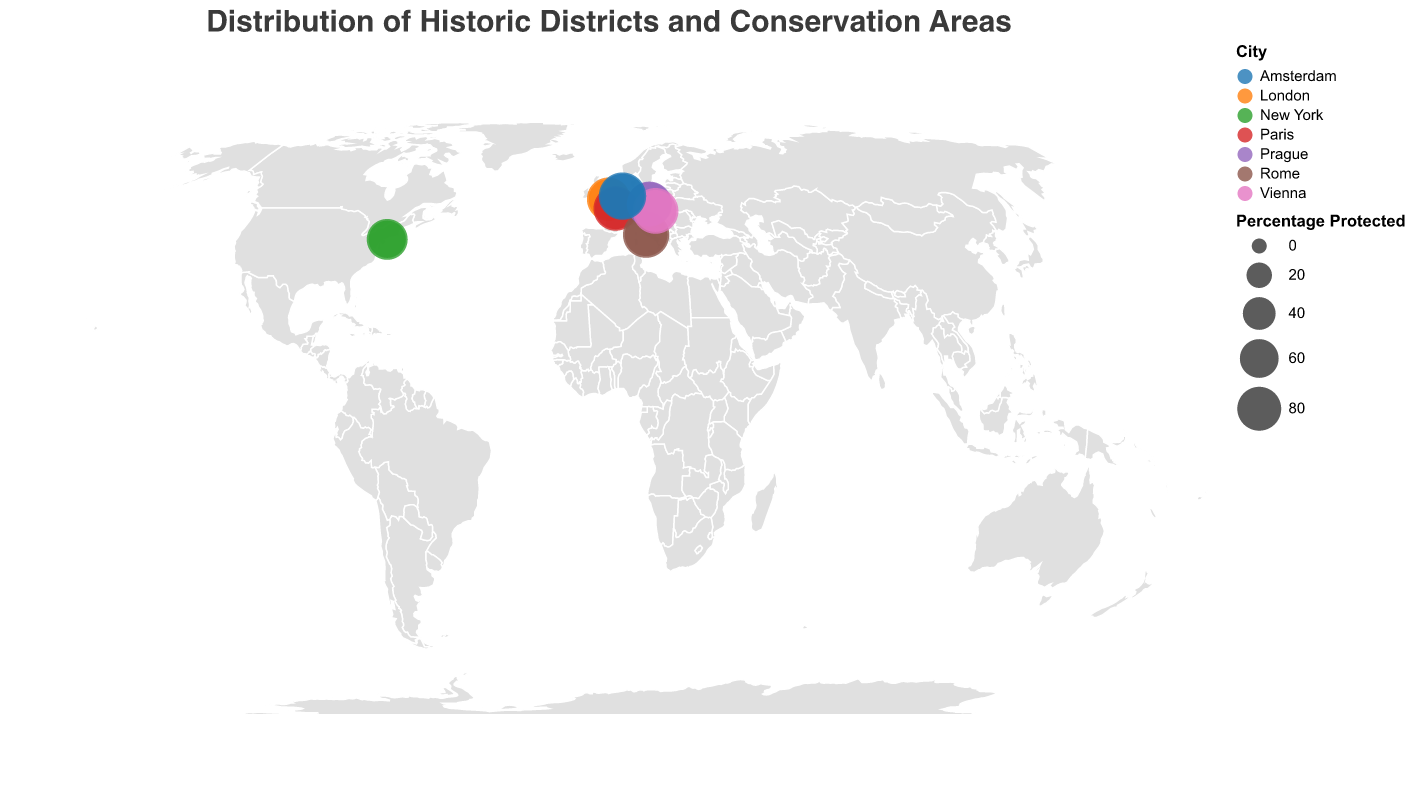What's the title of the figure? The title is prominently displayed at the top of the figure.
Answer: Distribution of Historic Districts and Conservation Areas Which city has the highest percentage of protected buildings in one of its districts? By looking at the size of the circles, Amsterdam's Canal Ring stands out with the largest circle, indicating the highest percentage.
Answer: Amsterdam What is the percentage of protected buildings in the Marais district of Paris? By hovering over the Marais district marker in Paris, the tooltip reveals the relevant information.
Answer: 82% How many districts in the figure have a percentage of protected buildings greater than 80%? Counting the districts with circles larger than those representing 80% shows that there are five districts: Westminster, Marais, Centro Storico, Old Town, Innere Stadt, Canal Ring, and Jordaan.
Answer: 7 Which city has the district with the smallest percentage of protected buildings? The city with the smallest circle is New York's Greenwich Village. Hovering over the marker confirms this.
Answer: New York Compare the percentage of protected buildings between the Old Town district in Prague and the Trastevere district in Rome. Which is higher and by how much? Old Town in Prague has 85% while Trastevere in Rome has 75%. Subtracting these gives 85% - 75% = 10%.
Answer: Old Town, 10% What's the average percentage of protected buildings in the districts of Amsterdam? Summing up percentages for the two districts (95% + 83%) and then dividing by 2 gives (95 + 83) / 2 = 89%.
Answer: 89% Is the percentage of protected buildings in Montmartre higher or lower than that in Brooklyn Heights? By comparing, Montmartre has 70% and Brooklyn Heights has 68%. Thus, Montmartre is higher.
Answer: Higher Identify the city with the greatest number of districts shown in the figure. The city with the most district markers is counted to be London, which has two: Westminster and City of London.
Answer: London Which district in Vienna has a higher percentage of protected buildings, Innere Stadt or Spittelberg? By comparing the markers, Innere Stadt has 88%, and Spittelberg has 72%. Thus, Innere Stadt is higher.
Answer: Innere Stadt 